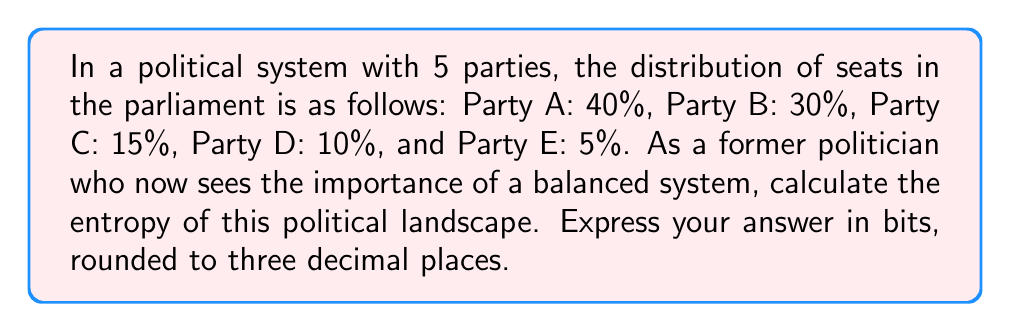Show me your answer to this math problem. To calculate the entropy of this political system, we'll use the Shannon entropy formula:

$$ H = -\sum_{i=1}^{n} p_i \log_2(p_i) $$

Where:
$H$ is the entropy
$n$ is the number of parties
$p_i$ is the probability (or in this case, the proportion of seats) for each party

Let's calculate for each party:

1. Party A: $p_1 = 0.40$
   $-0.40 \log_2(0.40) = 0.528321$

2. Party B: $p_2 = 0.30$
   $-0.30 \log_2(0.30) = 0.521126$

3. Party C: $p_3 = 0.15$
   $-0.15 \log_2(0.15) = 0.410239$

4. Party D: $p_4 = 0.10$
   $-0.10 \log_2(0.10) = 0.332193$

5. Party E: $p_5 = 0.05$
   $-0.05 \log_2(0.05) = 0.216096$

Now, we sum all these values:

$H = 0.528321 + 0.521126 + 0.410239 + 0.332193 + 0.216096 = 2.007975$

Rounding to three decimal places, we get 2.008 bits.
Answer: 2.008 bits 